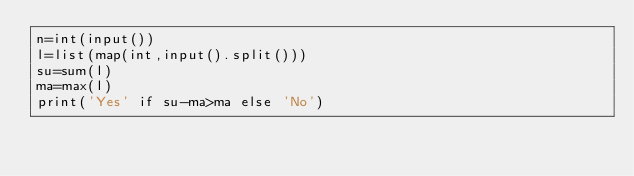Convert code to text. <code><loc_0><loc_0><loc_500><loc_500><_Python_>n=int(input())
l=list(map(int,input().split()))
su=sum(l)
ma=max(l)
print('Yes' if su-ma>ma else 'No')</code> 